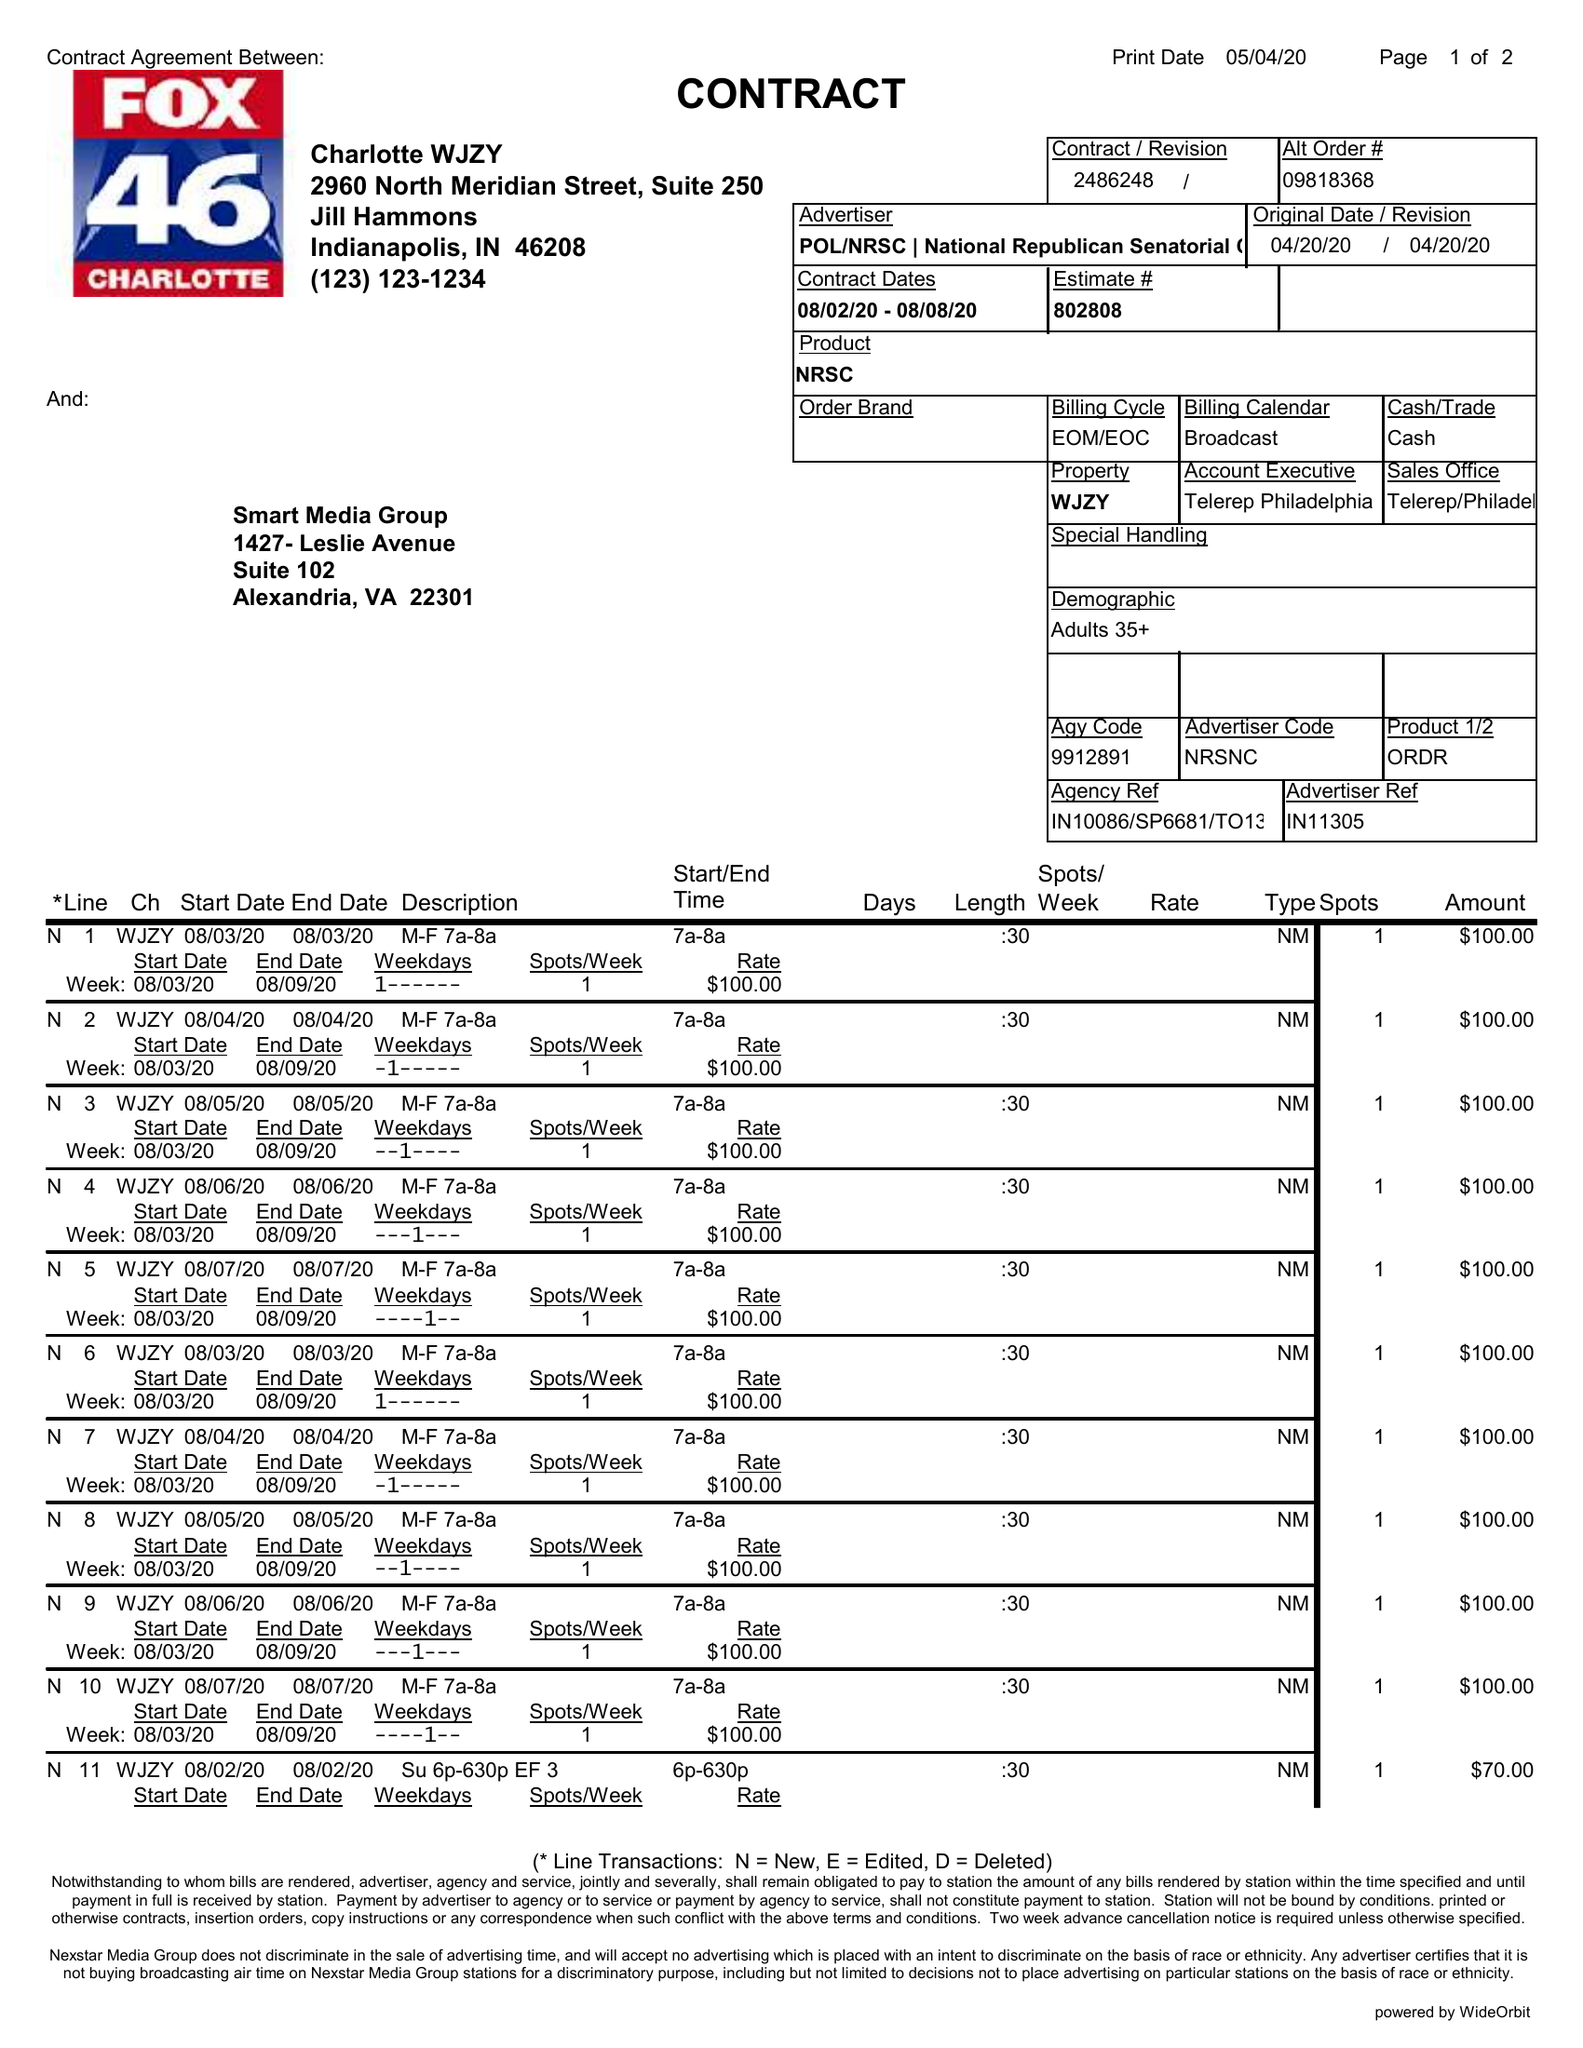What is the value for the flight_from?
Answer the question using a single word or phrase. 08/02/20 